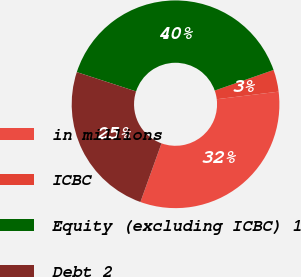Convert chart. <chart><loc_0><loc_0><loc_500><loc_500><pie_chart><fcel>in millions<fcel>ICBC<fcel>Equity (excluding ICBC) 1<fcel>Debt 2<nl><fcel>32.43%<fcel>3.42%<fcel>39.63%<fcel>24.52%<nl></chart> 